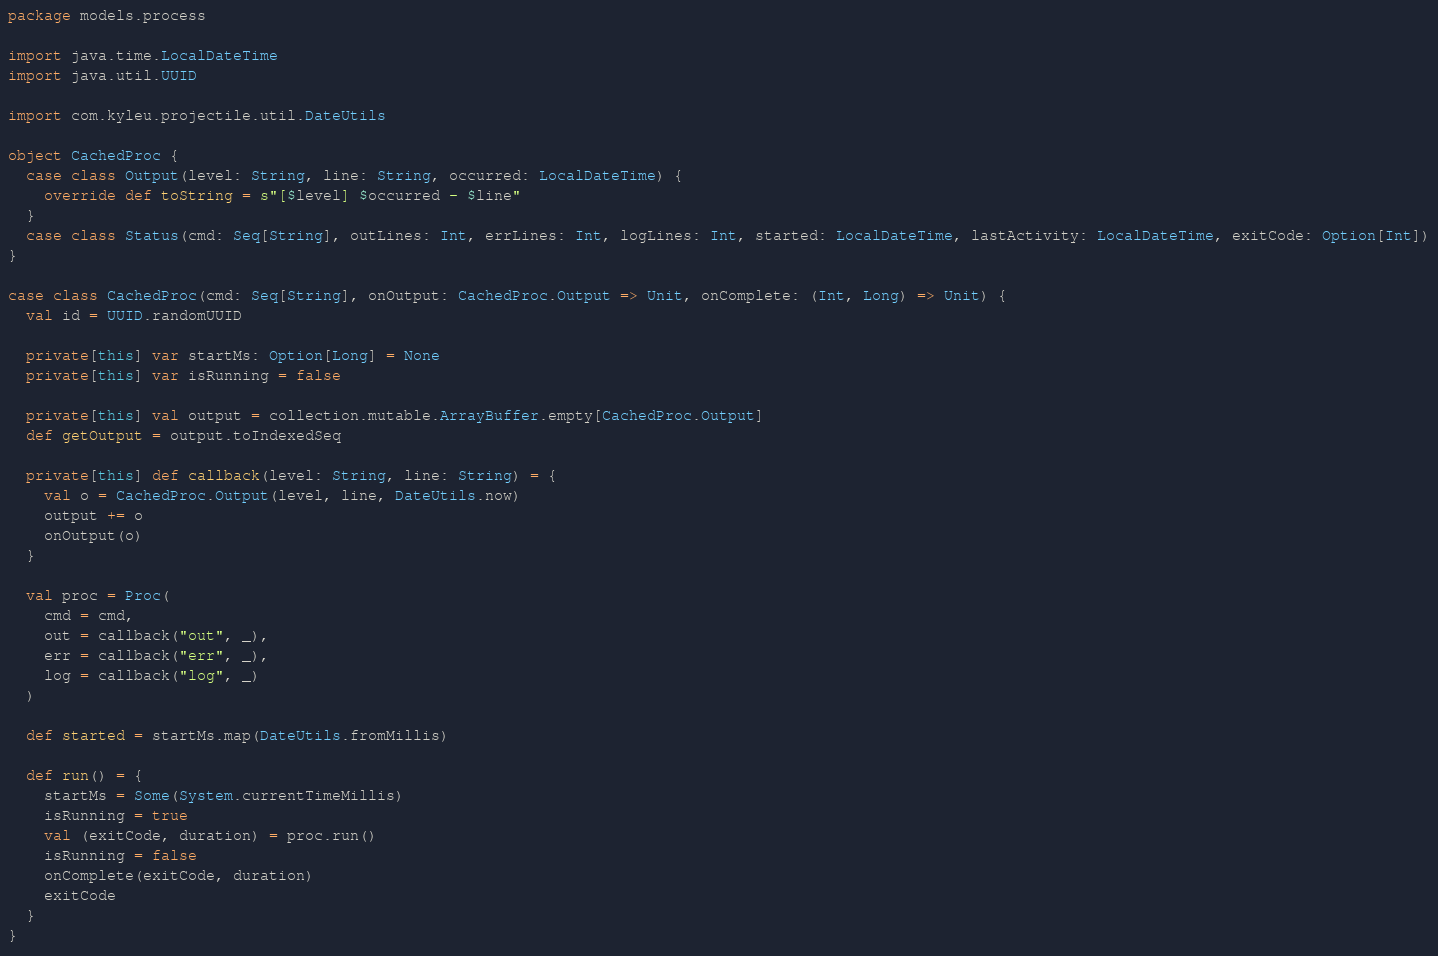<code> <loc_0><loc_0><loc_500><loc_500><_Scala_>package models.process

import java.time.LocalDateTime
import java.util.UUID

import com.kyleu.projectile.util.DateUtils

object CachedProc {
  case class Output(level: String, line: String, occurred: LocalDateTime) {
    override def toString = s"[$level] $occurred - $line"
  }
  case class Status(cmd: Seq[String], outLines: Int, errLines: Int, logLines: Int, started: LocalDateTime, lastActivity: LocalDateTime, exitCode: Option[Int])
}

case class CachedProc(cmd: Seq[String], onOutput: CachedProc.Output => Unit, onComplete: (Int, Long) => Unit) {
  val id = UUID.randomUUID

  private[this] var startMs: Option[Long] = None
  private[this] var isRunning = false

  private[this] val output = collection.mutable.ArrayBuffer.empty[CachedProc.Output]
  def getOutput = output.toIndexedSeq

  private[this] def callback(level: String, line: String) = {
    val o = CachedProc.Output(level, line, DateUtils.now)
    output += o
    onOutput(o)
  }

  val proc = Proc(
    cmd = cmd,
    out = callback("out", _),
    err = callback("err", _),
    log = callback("log", _)
  )

  def started = startMs.map(DateUtils.fromMillis)

  def run() = {
    startMs = Some(System.currentTimeMillis)
    isRunning = true
    val (exitCode, duration) = proc.run()
    isRunning = false
    onComplete(exitCode, duration)
    exitCode
  }
}
</code> 